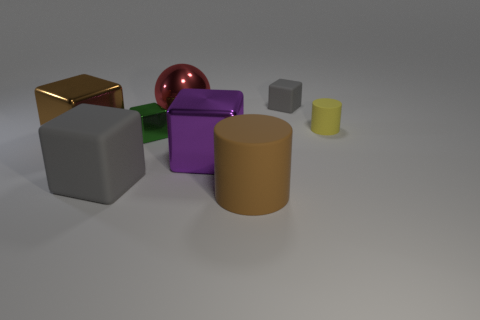Are there any other things that are the same shape as the big red thing?
Offer a very short reply. No. Does the large matte block have the same color as the small rubber cube?
Your response must be concise. Yes. How many things are both behind the small yellow matte cylinder and in front of the large matte block?
Your response must be concise. 0. What number of other big things have the same shape as the red object?
Offer a terse response. 0. There is a small matte thing in front of the gray thing that is on the right side of the big gray object; what is its color?
Make the answer very short. Yellow. Does the purple metal object have the same shape as the gray object that is on the left side of the tiny metallic thing?
Provide a succinct answer. Yes. There is a cylinder in front of the metal block that is left of the gray object in front of the big purple shiny object; what is it made of?
Provide a succinct answer. Rubber. Are there any other green blocks that have the same size as the green block?
Provide a succinct answer. No. There is a purple cube that is made of the same material as the brown block; what size is it?
Keep it short and to the point. Large. The big brown shiny thing is what shape?
Keep it short and to the point. Cube. 